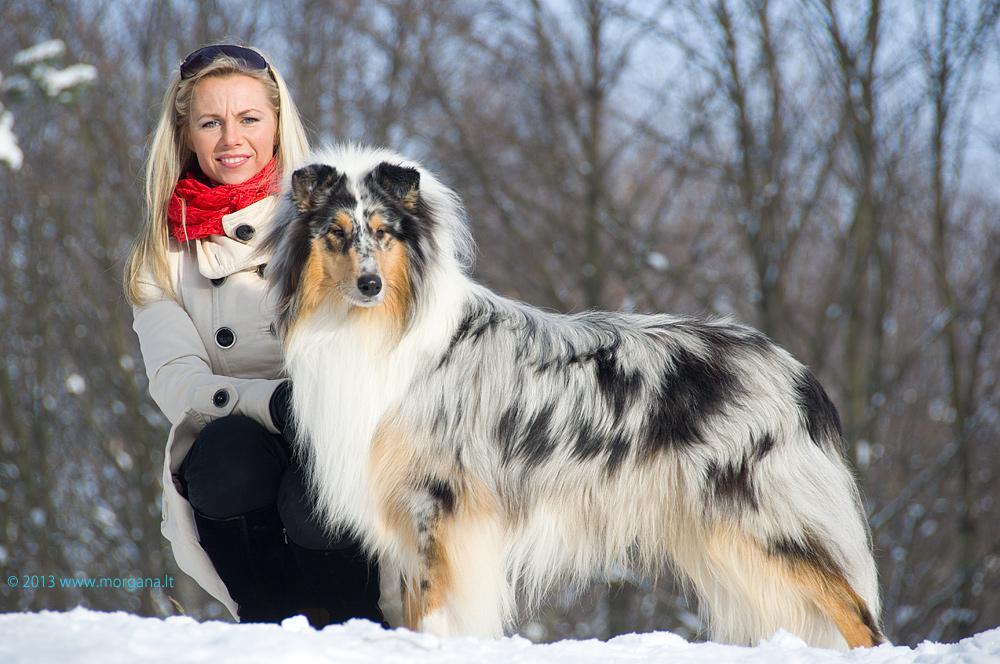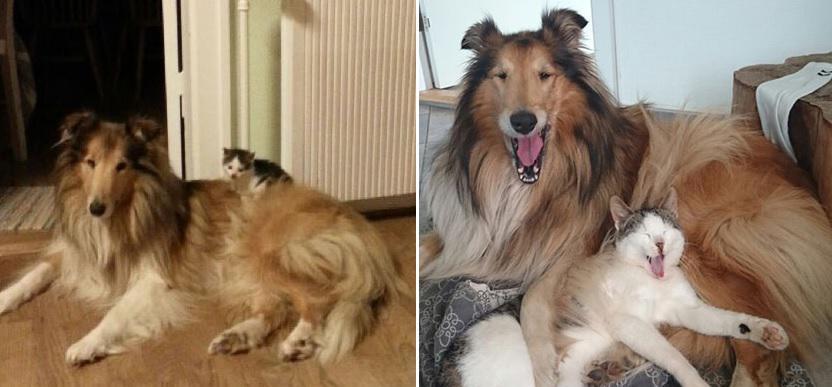The first image is the image on the left, the second image is the image on the right. Analyze the images presented: Is the assertion "Three collies pose together in both of the pictures." valid? Answer yes or no. No. The first image is the image on the left, the second image is the image on the right. Evaluate the accuracy of this statement regarding the images: "Each image contains exactly three dogs.". Is it true? Answer yes or no. No. 